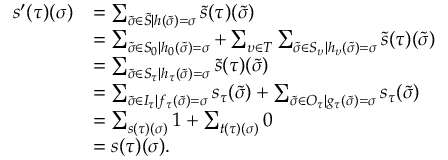<formula> <loc_0><loc_0><loc_500><loc_500>\begin{array} { r l } { s ^ { \prime } ( \tau ) ( \sigma ) } & { = \sum _ { \tilde { \sigma } \in \tilde { S } | h ( \tilde { \sigma } ) = \sigma } \tilde { s } ( \tau ) ( \tilde { \sigma } ) } \\ & { = \sum _ { \tilde { \sigma } \in S _ { 0 } | h _ { 0 } ( \tilde { \sigma } ) = \sigma } + \sum _ { \upsilon \in T } \sum _ { \tilde { \sigma } \in S _ { \upsilon } | h _ { \upsilon } ( \tilde { \sigma } ) = \sigma } \tilde { s } ( \tau ) ( \tilde { \sigma } ) } \\ & { = \sum _ { \tilde { \sigma } \in S _ { \tau } | h _ { \tau } ( \tilde { \sigma } ) = \sigma } \tilde { s } ( \tau ) ( \tilde { \sigma } ) } \\ & { = \sum _ { \tilde { \sigma } \in I _ { \tau } | f _ { \tau } ( \tilde { \sigma } ) = \sigma } s _ { \tau } ( \tilde { \sigma } ) + \sum _ { \tilde { \sigma } \in O _ { \tau } | g _ { \tau } ( \tilde { \sigma } ) = \sigma } s _ { \tau } ( \tilde { \sigma } ) } \\ & { = \sum _ { s ( \tau ) ( \sigma ) } 1 + \sum _ { t ( \tau ) ( \sigma ) } 0 } \\ & { = s ( \tau ) ( \sigma ) . } \end{array}</formula> 